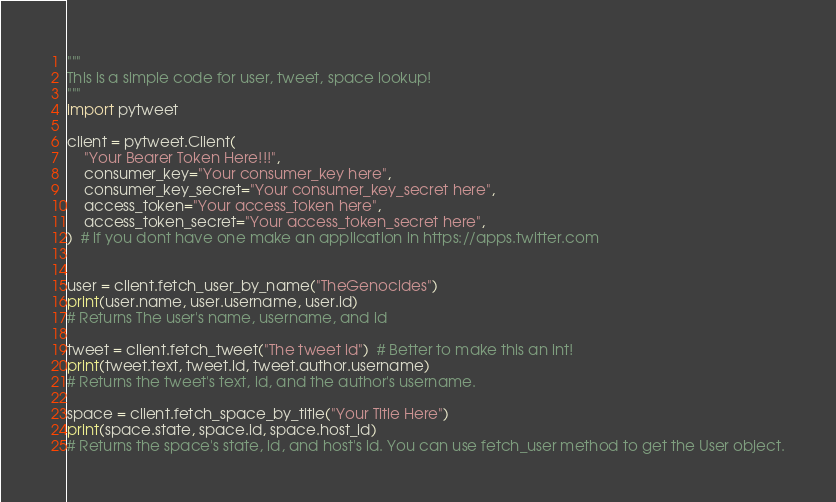Convert code to text. <code><loc_0><loc_0><loc_500><loc_500><_Python_>"""
This is a simple code for user, tweet, space lookup!
"""
import pytweet

client = pytweet.Client(
    "Your Bearer Token Here!!!",
    consumer_key="Your consumer_key here",
    consumer_key_secret="Your consumer_key_secret here",
    access_token="Your access_token here",
    access_token_secret="Your access_token_secret here",
)  # if you dont have one make an application in https://apps.twitter.com


user = client.fetch_user_by_name("TheGenocides")
print(user.name, user.username, user.id)
# Returns The user's name, username, and id

tweet = client.fetch_tweet("The tweet id")  # Better to make this an int!
print(tweet.text, tweet.id, tweet.author.username)
# Returns the tweet's text, id, and the author's username.

space = client.fetch_space_by_title("Your Title Here")
print(space.state, space.id, space.host_id)
# Returns the space's state, id, and host's id. You can use fetch_user method to get the User object.
</code> 